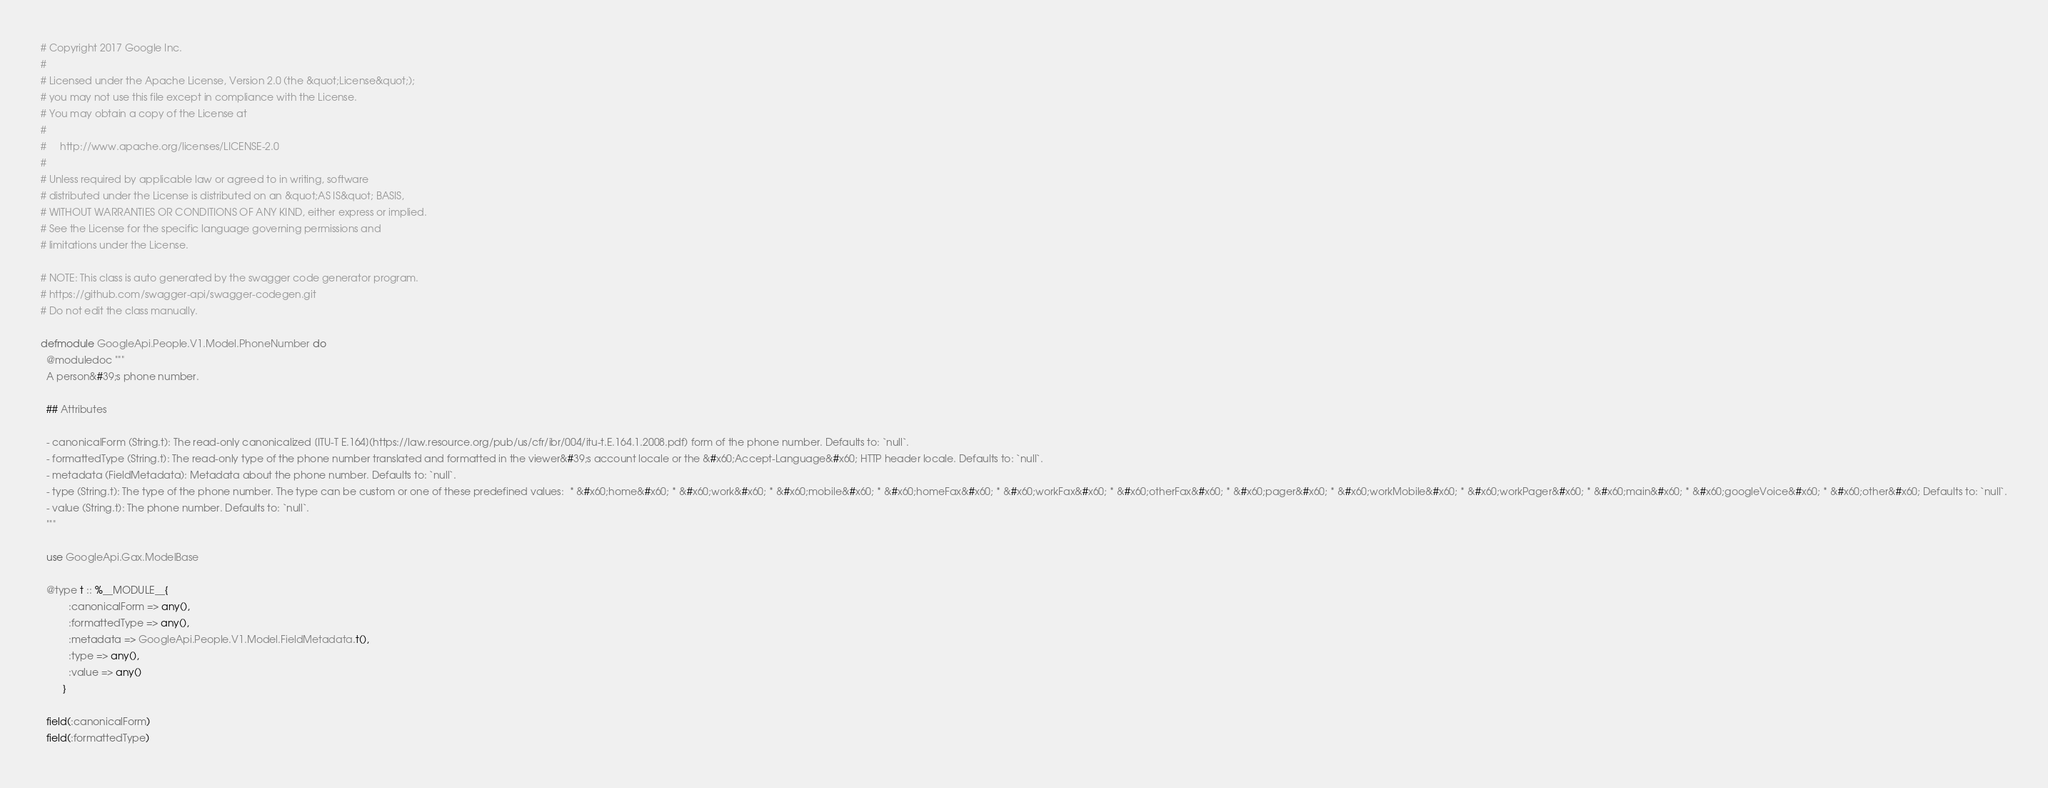<code> <loc_0><loc_0><loc_500><loc_500><_Elixir_># Copyright 2017 Google Inc.
#
# Licensed under the Apache License, Version 2.0 (the &quot;License&quot;);
# you may not use this file except in compliance with the License.
# You may obtain a copy of the License at
#
#     http://www.apache.org/licenses/LICENSE-2.0
#
# Unless required by applicable law or agreed to in writing, software
# distributed under the License is distributed on an &quot;AS IS&quot; BASIS,
# WITHOUT WARRANTIES OR CONDITIONS OF ANY KIND, either express or implied.
# See the License for the specific language governing permissions and
# limitations under the License.

# NOTE: This class is auto generated by the swagger code generator program.
# https://github.com/swagger-api/swagger-codegen.git
# Do not edit the class manually.

defmodule GoogleApi.People.V1.Model.PhoneNumber do
  @moduledoc """
  A person&#39;s phone number.

  ## Attributes

  - canonicalForm (String.t): The read-only canonicalized [ITU-T E.164](https://law.resource.org/pub/us/cfr/ibr/004/itu-t.E.164.1.2008.pdf) form of the phone number. Defaults to: `null`.
  - formattedType (String.t): The read-only type of the phone number translated and formatted in the viewer&#39;s account locale or the &#x60;Accept-Language&#x60; HTTP header locale. Defaults to: `null`.
  - metadata (FieldMetadata): Metadata about the phone number. Defaults to: `null`.
  - type (String.t): The type of the phone number. The type can be custom or one of these predefined values:  * &#x60;home&#x60; * &#x60;work&#x60; * &#x60;mobile&#x60; * &#x60;homeFax&#x60; * &#x60;workFax&#x60; * &#x60;otherFax&#x60; * &#x60;pager&#x60; * &#x60;workMobile&#x60; * &#x60;workPager&#x60; * &#x60;main&#x60; * &#x60;googleVoice&#x60; * &#x60;other&#x60; Defaults to: `null`.
  - value (String.t): The phone number. Defaults to: `null`.
  """

  use GoogleApi.Gax.ModelBase

  @type t :: %__MODULE__{
          :canonicalForm => any(),
          :formattedType => any(),
          :metadata => GoogleApi.People.V1.Model.FieldMetadata.t(),
          :type => any(),
          :value => any()
        }

  field(:canonicalForm)
  field(:formattedType)</code> 